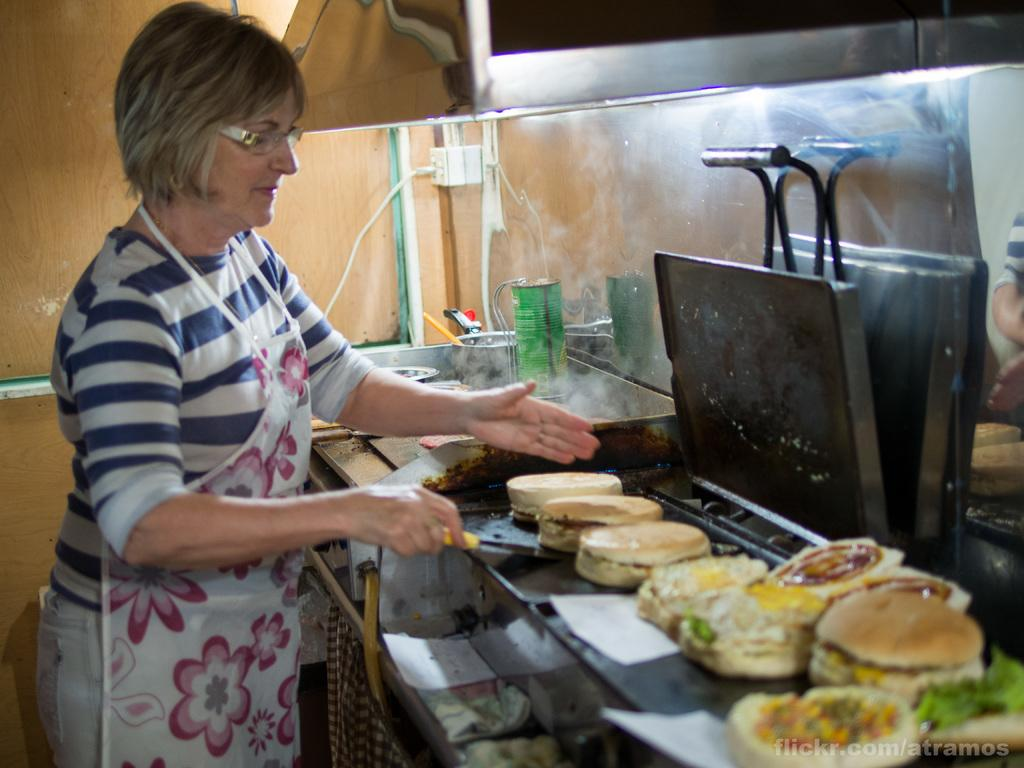Who is present in the image? There is a woman in the image. What is the woman wearing? The woman is wearing an apron. What is the woman holding in the image? The woman is holding a spatula. What can be seen in the image besides the woman? There is food visible in the image, and there are objects in the background. What is present on the wall in the background? There is a socket on the wall in the background. What type of straw is the committee using to spy on the woman in the image? There is no straw, committee, or spying activity present in the image. 